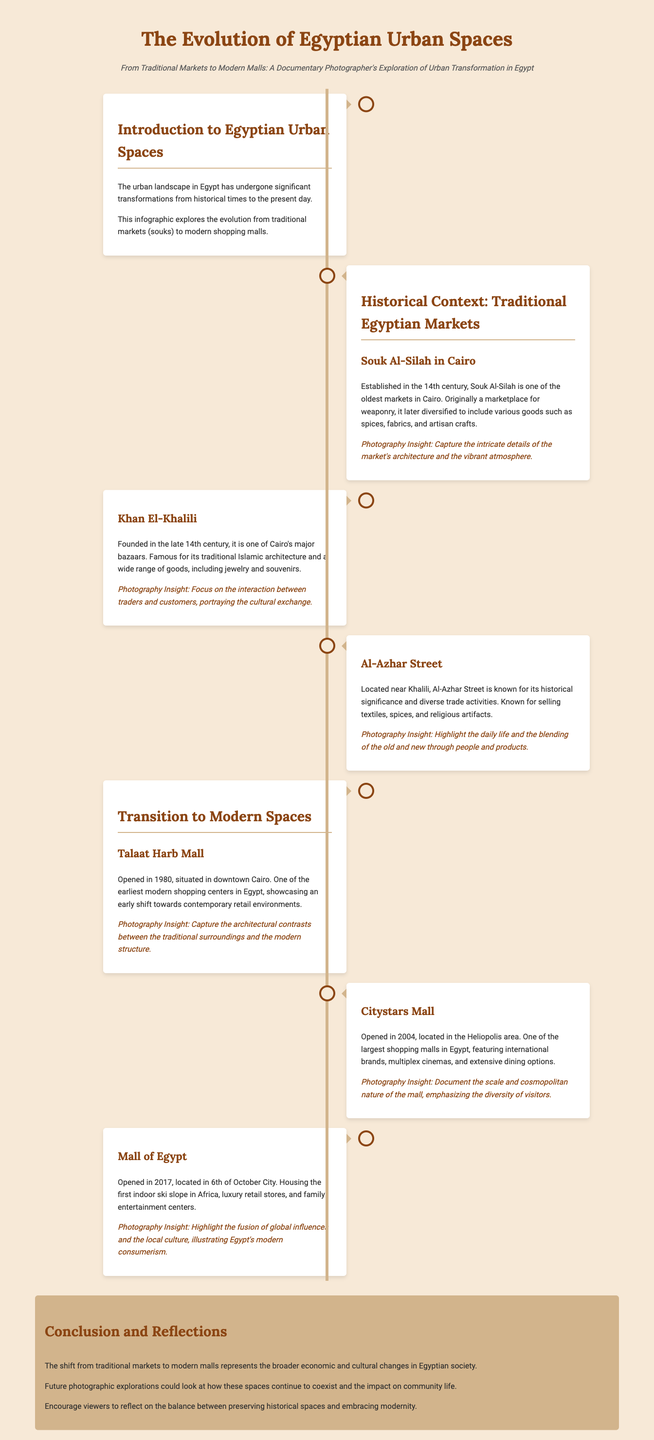What is the title of the infographic? The title provides an overview of the main subject covered, which is the evolution of urban spaces in Egypt.
Answer: The Evolution of Egyptian Urban Spaces What century was Souk Al-Silah established? The establishment date signifies the historical importance and context of traditional markets.
Answer: 14th century In which year did Talaat Harb Mall open? The opening year exemplifies the transition towards modern shopping spaces in Egypt.
Answer: 1980 What is a key feature of the Mall of Egypt? This feature highlights the unique offerings of modern shopping centers that attract visitors.
Answer: Indoor ski slope Which market is known for its traditional Islamic architecture? The architectural style is significant in understanding the cultural heritage of the market.
Answer: Khan El-Khalili What does the conclusion reflect on? The conclusion sheds light on the implications of urban transformation on community life.
Answer: The balance between preserving historical spaces and embracing modernity What year was Citystars Mall opened? This information illustrates the timeline of modern retail development in Egypt.
Answer: 2004 What type of products can be found in Al-Azhar Street? This question targets the variety of goods sold in historical markets, important for understanding cultural trade.
Answer: Textiles, spices, and religious artifacts 